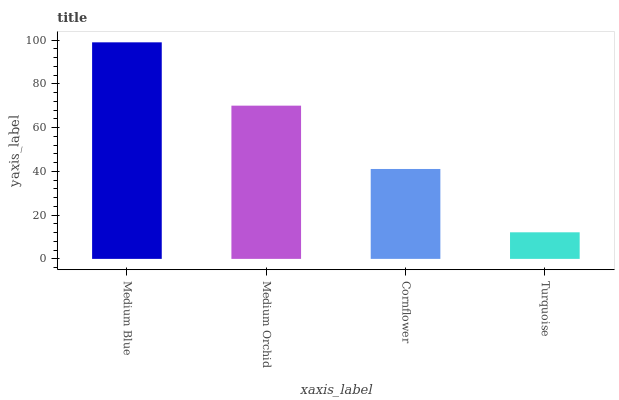Is Turquoise the minimum?
Answer yes or no. Yes. Is Medium Blue the maximum?
Answer yes or no. Yes. Is Medium Orchid the minimum?
Answer yes or no. No. Is Medium Orchid the maximum?
Answer yes or no. No. Is Medium Blue greater than Medium Orchid?
Answer yes or no. Yes. Is Medium Orchid less than Medium Blue?
Answer yes or no. Yes. Is Medium Orchid greater than Medium Blue?
Answer yes or no. No. Is Medium Blue less than Medium Orchid?
Answer yes or no. No. Is Medium Orchid the high median?
Answer yes or no. Yes. Is Cornflower the low median?
Answer yes or no. Yes. Is Medium Blue the high median?
Answer yes or no. No. Is Medium Orchid the low median?
Answer yes or no. No. 